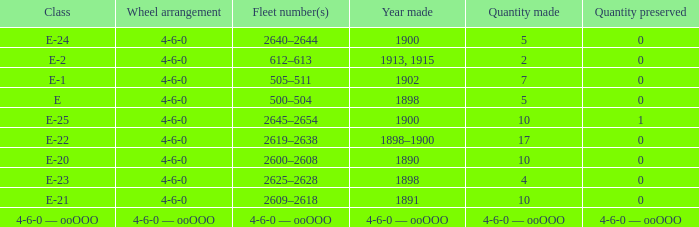What is the wheel arrangement with 1 quantity preserved? 4-6-0. 